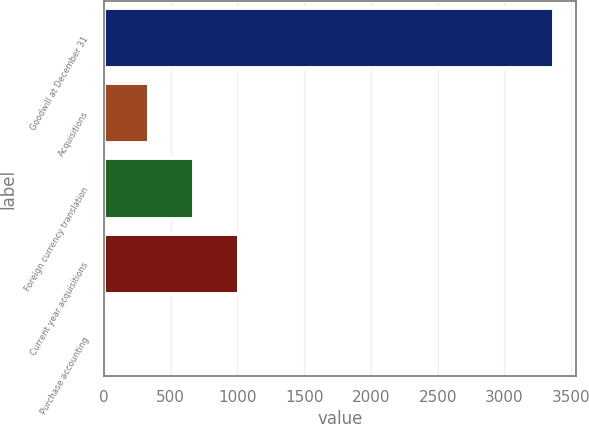<chart> <loc_0><loc_0><loc_500><loc_500><bar_chart><fcel>Goodwill at December 31<fcel>Acquisitions<fcel>Foreign currency translation<fcel>Current year acquisitions<fcel>Purchase accounting<nl><fcel>3368.7<fcel>340.83<fcel>677.26<fcel>1013.69<fcel>4.4<nl></chart> 